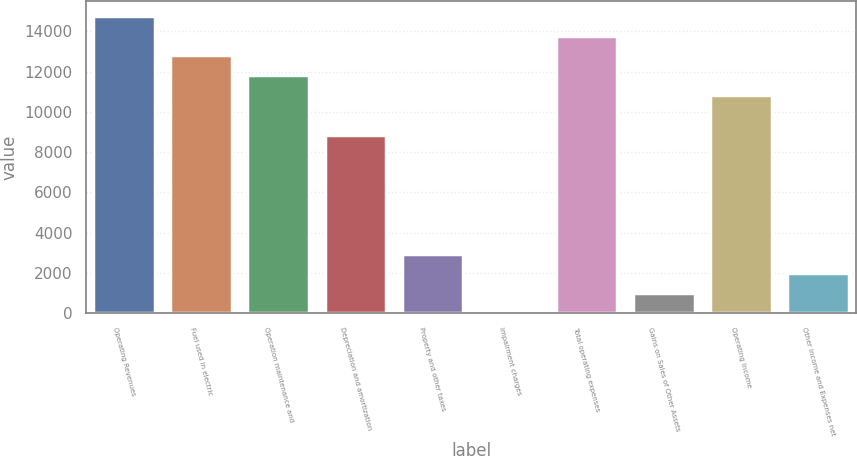<chart> <loc_0><loc_0><loc_500><loc_500><bar_chart><fcel>Operating Revenues<fcel>Fuel used in electric<fcel>Operation maintenance and<fcel>Depreciation and amortization<fcel>Property and other taxes<fcel>Impairment charges<fcel>Total operating expenses<fcel>Gains on Sales of Other Assets<fcel>Operating Income<fcel>Other Income and Expenses net<nl><fcel>14776<fcel>12806.8<fcel>11822.2<fcel>8868.4<fcel>2960.8<fcel>7<fcel>13791.4<fcel>991.6<fcel>10837.6<fcel>1976.2<nl></chart> 